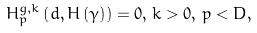Convert formula to latex. <formula><loc_0><loc_0><loc_500><loc_500>H _ { p } ^ { g , k } \left ( d , H \left ( \gamma \right ) \right ) = 0 , \, k > 0 , \, p < D ,</formula> 